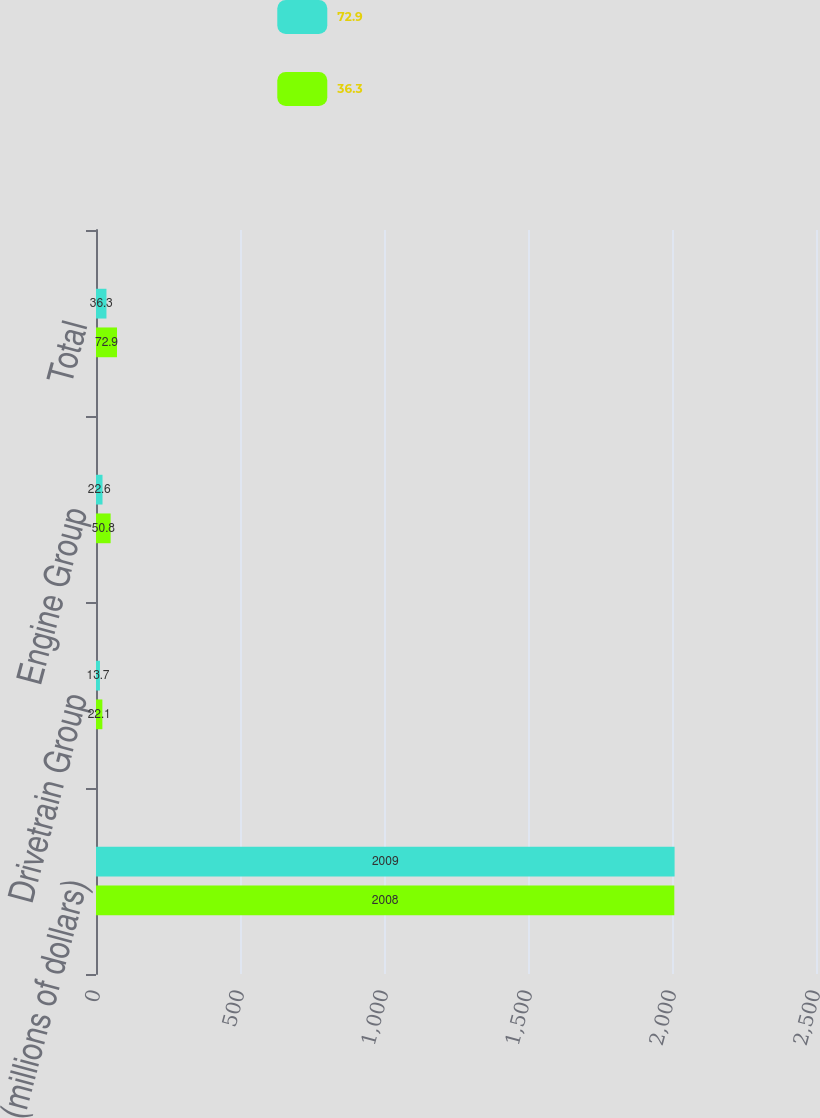Convert chart to OTSL. <chart><loc_0><loc_0><loc_500><loc_500><stacked_bar_chart><ecel><fcel>(millions of dollars)<fcel>Drivetrain Group<fcel>Engine Group<fcel>Total<nl><fcel>72.9<fcel>2009<fcel>13.7<fcel>22.6<fcel>36.3<nl><fcel>36.3<fcel>2008<fcel>22.1<fcel>50.8<fcel>72.9<nl></chart> 